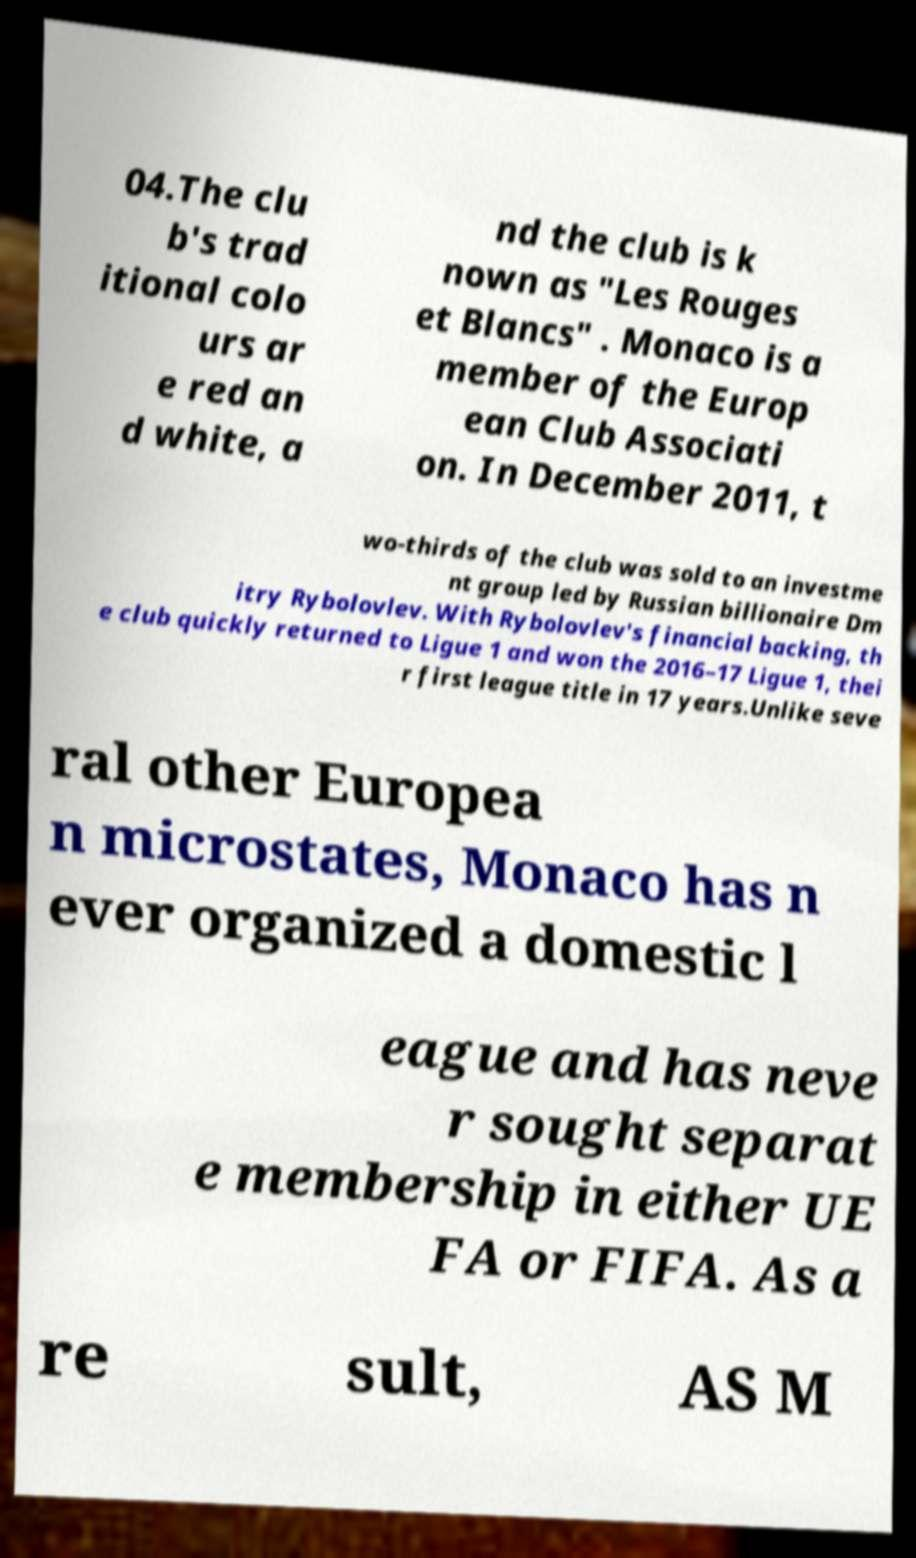Could you extract and type out the text from this image? 04.The clu b's trad itional colo urs ar e red an d white, a nd the club is k nown as "Les Rouges et Blancs" . Monaco is a member of the Europ ean Club Associati on. In December 2011, t wo-thirds of the club was sold to an investme nt group led by Russian billionaire Dm itry Rybolovlev. With Rybolovlev's financial backing, th e club quickly returned to Ligue 1 and won the 2016–17 Ligue 1, thei r first league title in 17 years.Unlike seve ral other Europea n microstates, Monaco has n ever organized a domestic l eague and has neve r sought separat e membership in either UE FA or FIFA. As a re sult, AS M 